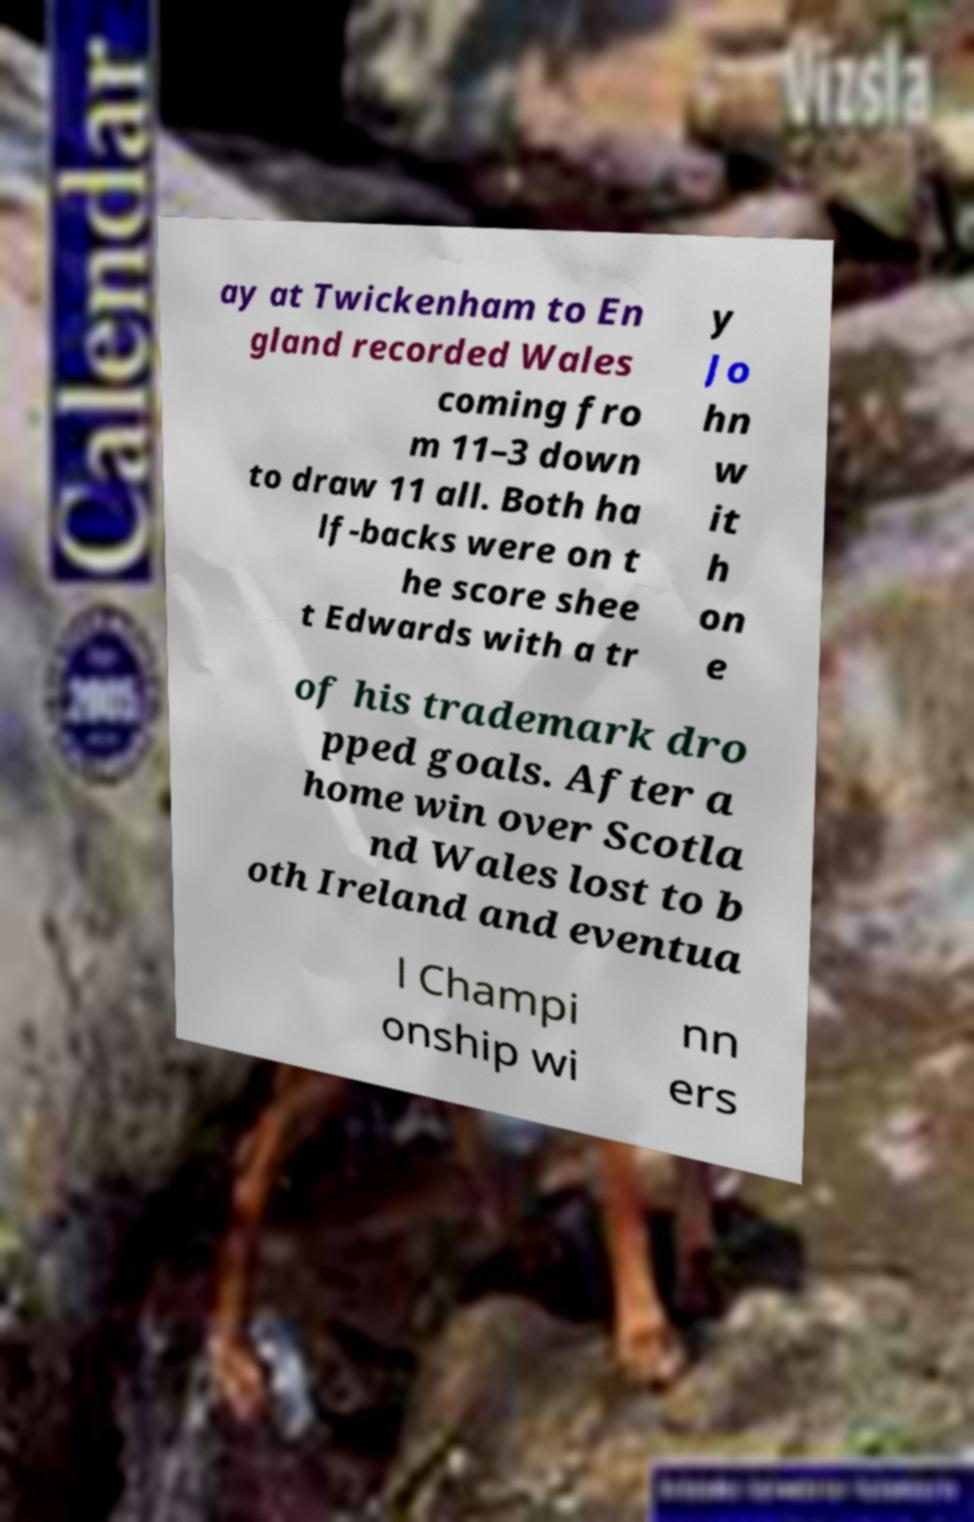What messages or text are displayed in this image? I need them in a readable, typed format. ay at Twickenham to En gland recorded Wales coming fro m 11–3 down to draw 11 all. Both ha lf-backs were on t he score shee t Edwards with a tr y Jo hn w it h on e of his trademark dro pped goals. After a home win over Scotla nd Wales lost to b oth Ireland and eventua l Champi onship wi nn ers 